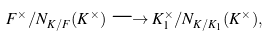<formula> <loc_0><loc_0><loc_500><loc_500>F ^ { \times } / N _ { K / F } ( K ^ { \times } ) \longrightarrow K ^ { \times } _ { 1 } / N _ { K / K _ { 1 } } ( K ^ { \times } ) ,</formula> 